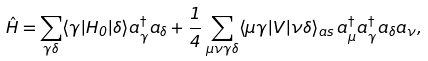Convert formula to latex. <formula><loc_0><loc_0><loc_500><loc_500>\hat { H } = \sum _ { \gamma \delta } \langle \gamma | H _ { 0 } | \delta \rangle a ^ { \dagger } _ { \gamma } a _ { \delta } + \frac { 1 } { 4 } \sum _ { \mu \nu \gamma \delta } \langle \mu \gamma | V | \nu \delta \rangle _ { a s } \, a ^ { \dagger } _ { \mu } a ^ { \dagger } _ { \gamma } a _ { \delta } a _ { \nu } ,</formula> 